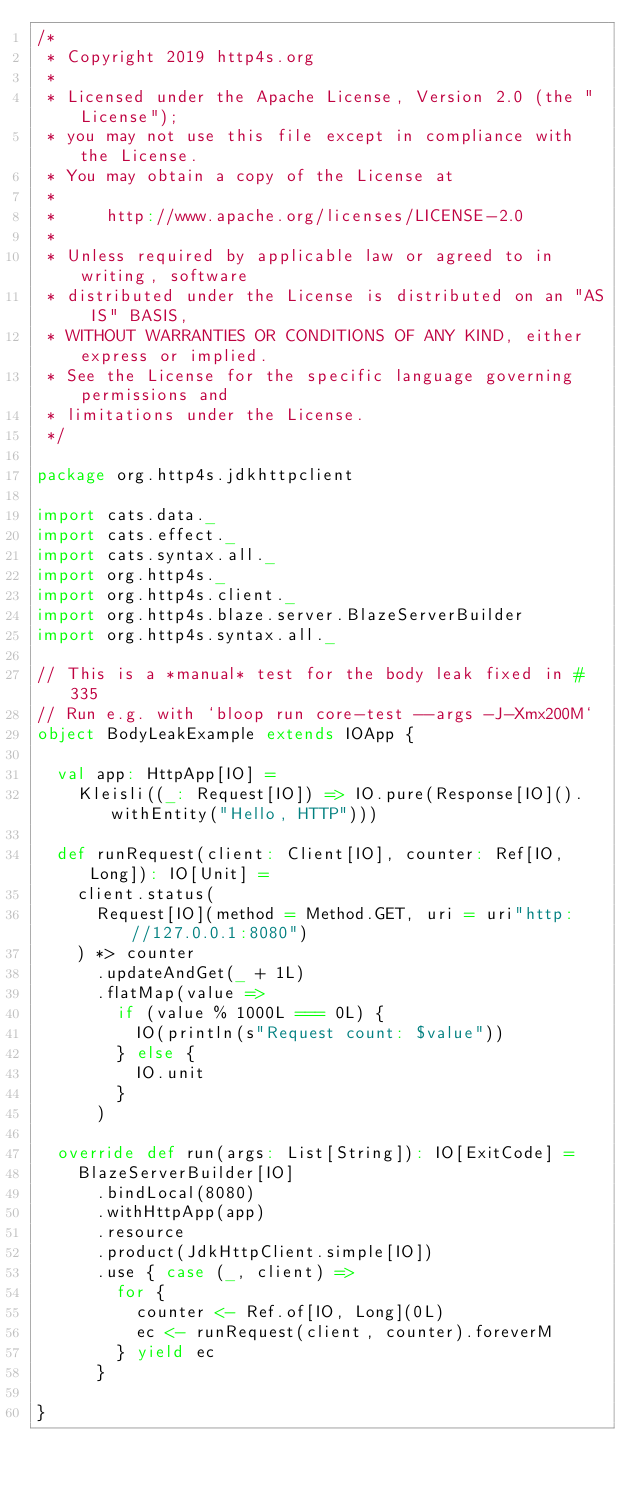Convert code to text. <code><loc_0><loc_0><loc_500><loc_500><_Scala_>/*
 * Copyright 2019 http4s.org
 *
 * Licensed under the Apache License, Version 2.0 (the "License");
 * you may not use this file except in compliance with the License.
 * You may obtain a copy of the License at
 *
 *     http://www.apache.org/licenses/LICENSE-2.0
 *
 * Unless required by applicable law or agreed to in writing, software
 * distributed under the License is distributed on an "AS IS" BASIS,
 * WITHOUT WARRANTIES OR CONDITIONS OF ANY KIND, either express or implied.
 * See the License for the specific language governing permissions and
 * limitations under the License.
 */

package org.http4s.jdkhttpclient

import cats.data._
import cats.effect._
import cats.syntax.all._
import org.http4s._
import org.http4s.client._
import org.http4s.blaze.server.BlazeServerBuilder
import org.http4s.syntax.all._

// This is a *manual* test for the body leak fixed in #335
// Run e.g. with `bloop run core-test --args -J-Xmx200M`
object BodyLeakExample extends IOApp {

  val app: HttpApp[IO] =
    Kleisli((_: Request[IO]) => IO.pure(Response[IO]().withEntity("Hello, HTTP")))

  def runRequest(client: Client[IO], counter: Ref[IO, Long]): IO[Unit] =
    client.status(
      Request[IO](method = Method.GET, uri = uri"http://127.0.0.1:8080")
    ) *> counter
      .updateAndGet(_ + 1L)
      .flatMap(value =>
        if (value % 1000L === 0L) {
          IO(println(s"Request count: $value"))
        } else {
          IO.unit
        }
      )

  override def run(args: List[String]): IO[ExitCode] =
    BlazeServerBuilder[IO]
      .bindLocal(8080)
      .withHttpApp(app)
      .resource
      .product(JdkHttpClient.simple[IO])
      .use { case (_, client) =>
        for {
          counter <- Ref.of[IO, Long](0L)
          ec <- runRequest(client, counter).foreverM
        } yield ec
      }

}
</code> 